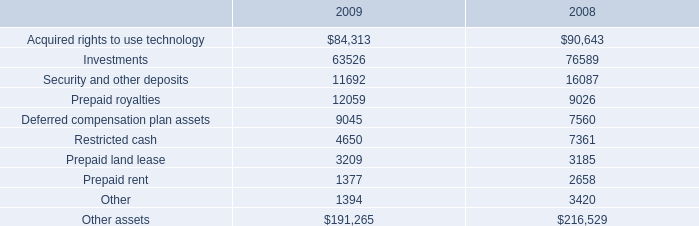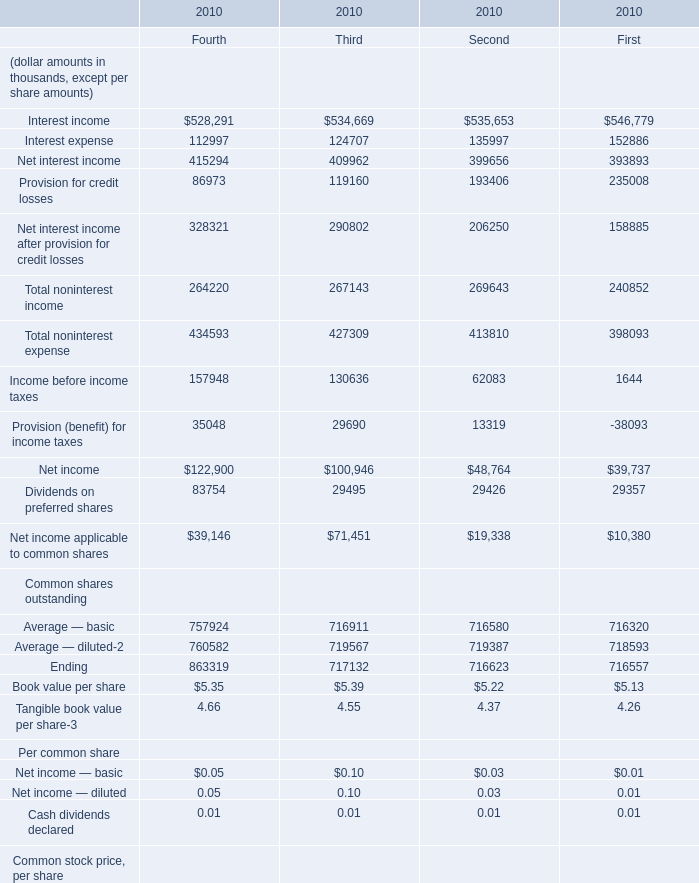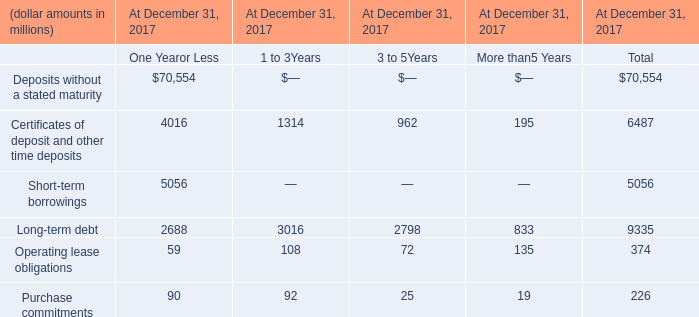what's the total amount of Acquired rights to use technology of 2008, Interest income of 2010 Fourth, and Income before income taxes of 2010 Fourth ? 
Computations: ((90643.0 + 528291.0) + 157948.0)
Answer: 776882.0. 